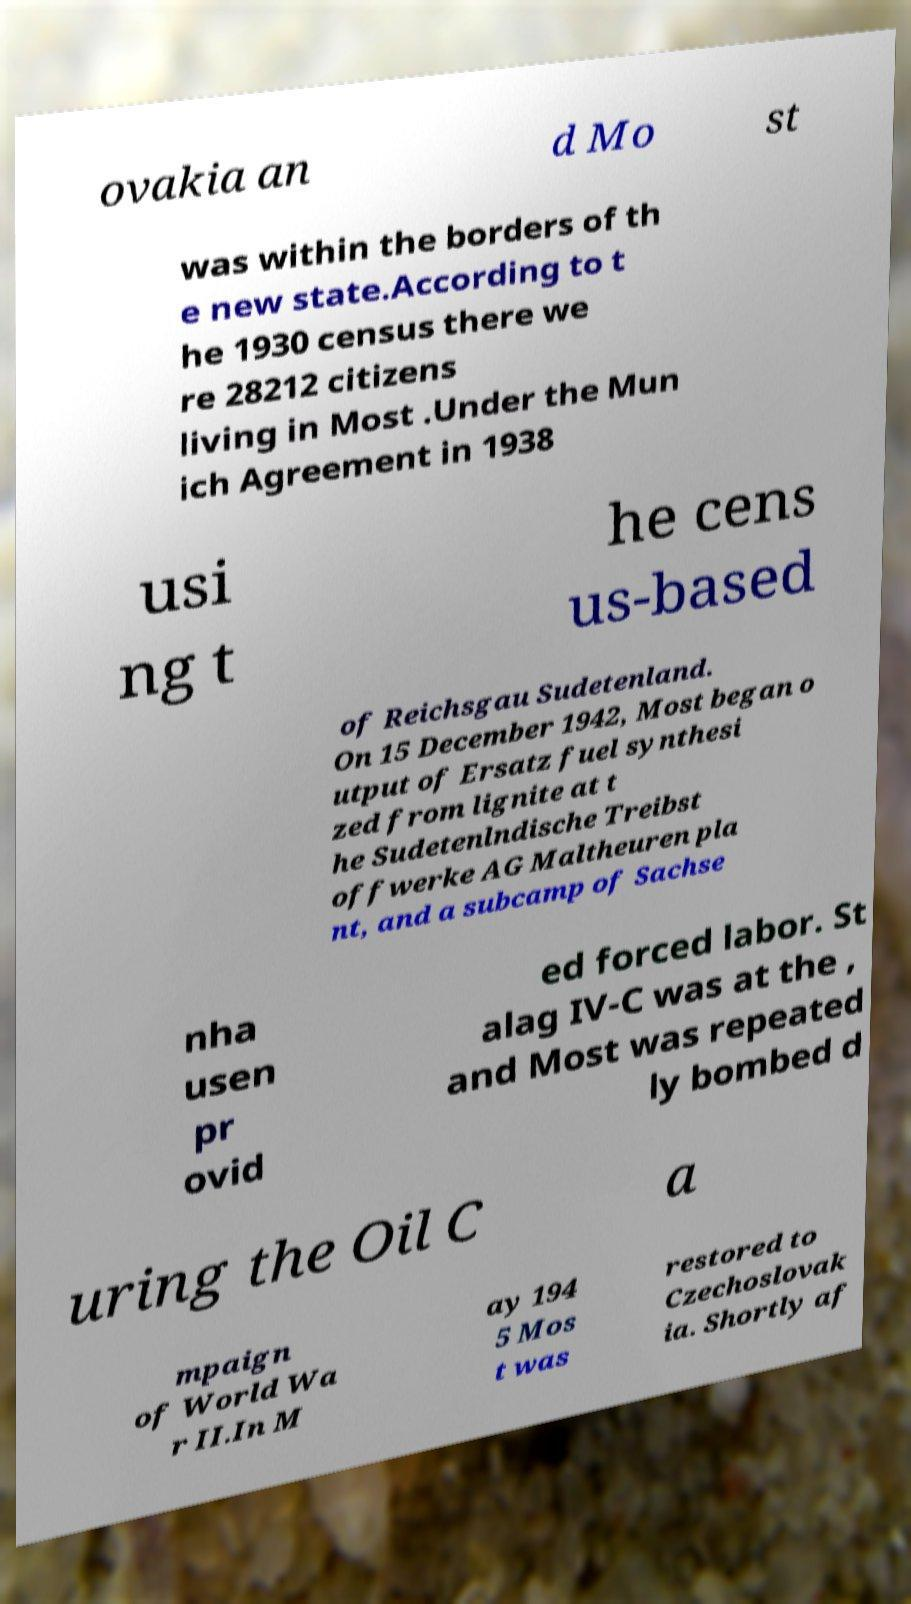I need the written content from this picture converted into text. Can you do that? ovakia an d Mo st was within the borders of th e new state.According to t he 1930 census there we re 28212 citizens living in Most .Under the Mun ich Agreement in 1938 usi ng t he cens us-based of Reichsgau Sudetenland. On 15 December 1942, Most began o utput of Ersatz fuel synthesi zed from lignite at t he Sudetenlndische Treibst offwerke AG Maltheuren pla nt, and a subcamp of Sachse nha usen pr ovid ed forced labor. St alag IV-C was at the , and Most was repeated ly bombed d uring the Oil C a mpaign of World Wa r II.In M ay 194 5 Mos t was restored to Czechoslovak ia. Shortly af 